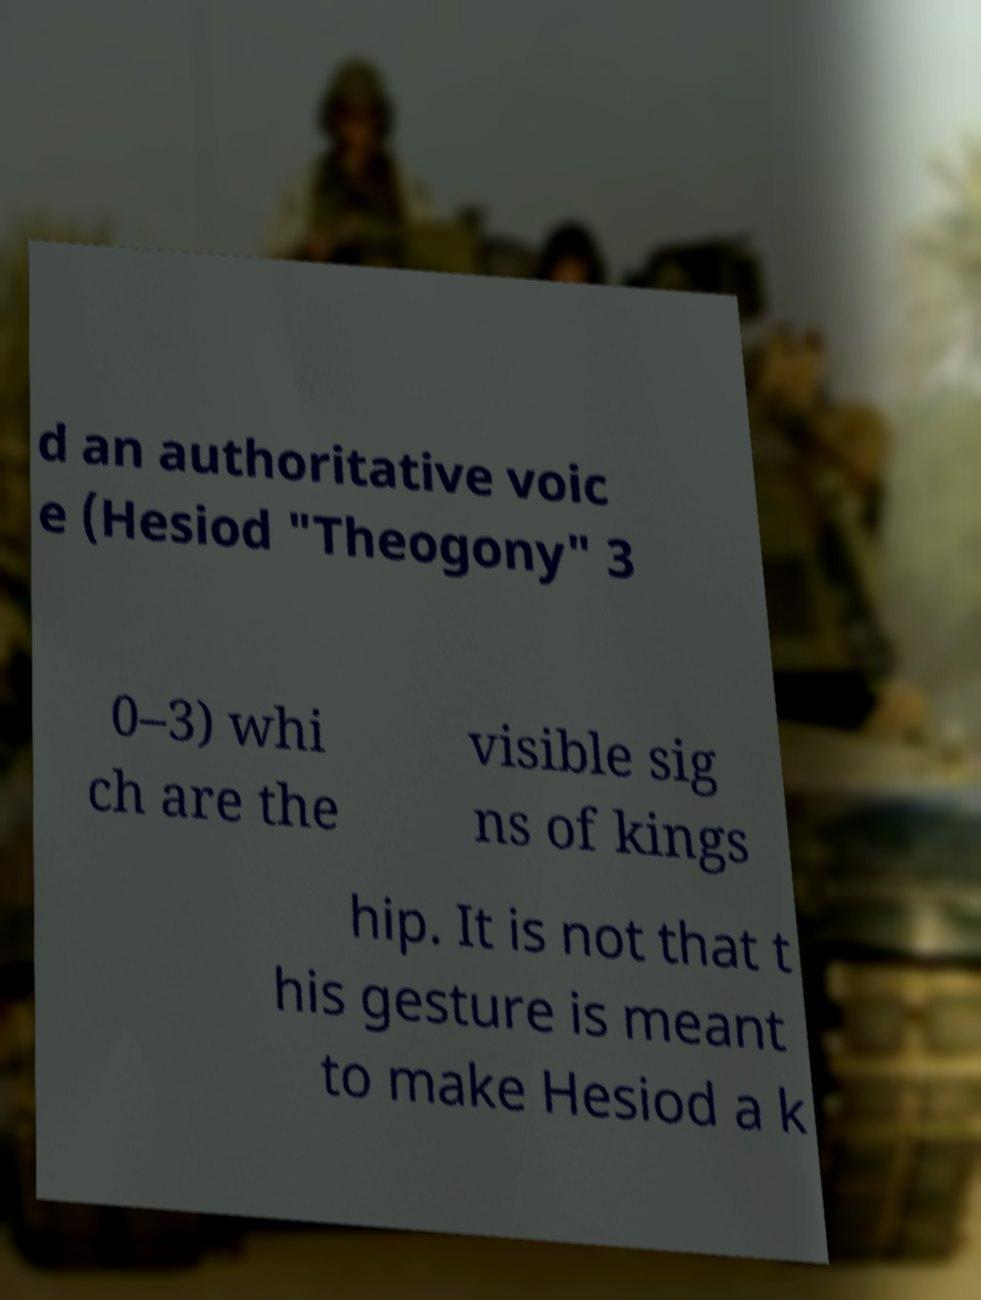Could you extract and type out the text from this image? d an authoritative voic e (Hesiod "Theogony" 3 0–3) whi ch are the visible sig ns of kings hip. It is not that t his gesture is meant to make Hesiod a k 